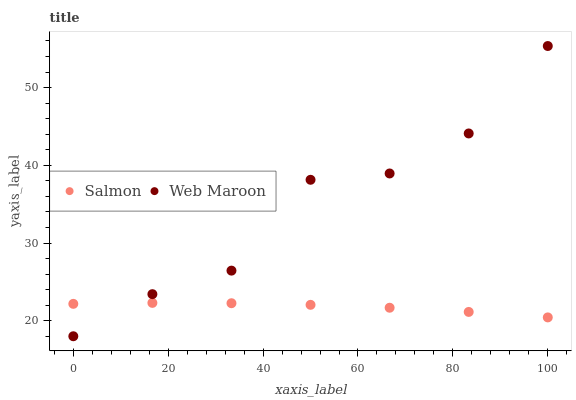Does Salmon have the minimum area under the curve?
Answer yes or no. Yes. Does Web Maroon have the maximum area under the curve?
Answer yes or no. Yes. Does Salmon have the maximum area under the curve?
Answer yes or no. No. Is Salmon the smoothest?
Answer yes or no. Yes. Is Web Maroon the roughest?
Answer yes or no. Yes. Is Salmon the roughest?
Answer yes or no. No. Does Web Maroon have the lowest value?
Answer yes or no. Yes. Does Salmon have the lowest value?
Answer yes or no. No. Does Web Maroon have the highest value?
Answer yes or no. Yes. Does Salmon have the highest value?
Answer yes or no. No. Does Salmon intersect Web Maroon?
Answer yes or no. Yes. Is Salmon less than Web Maroon?
Answer yes or no. No. Is Salmon greater than Web Maroon?
Answer yes or no. No. 